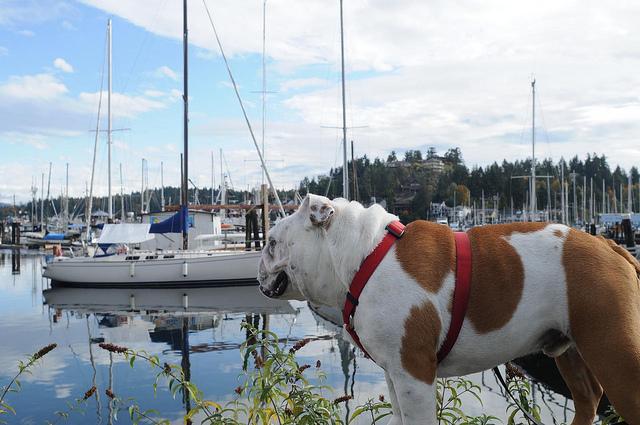What color is the dog's harness?
Write a very short answer. Red. How many horses so you see?
Give a very brief answer. 0. What breed of dog is this?
Give a very brief answer. Bulldog. 